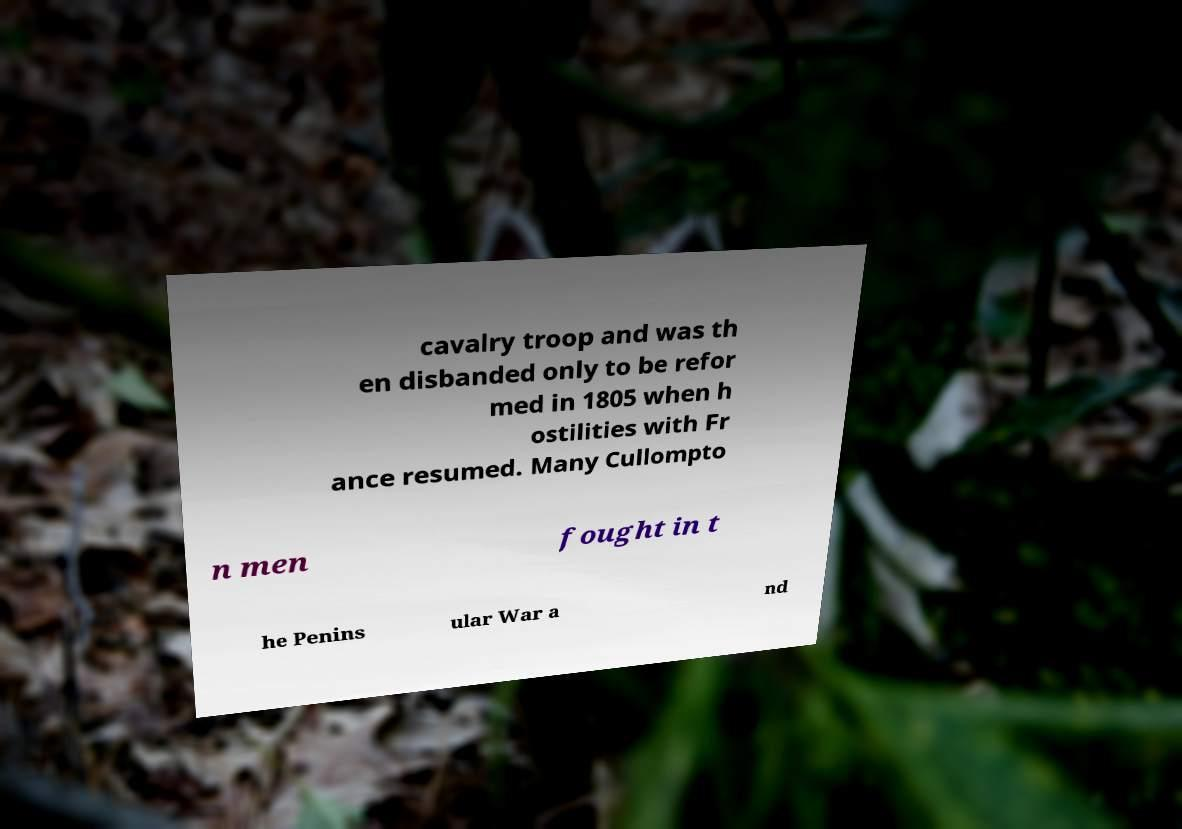I need the written content from this picture converted into text. Can you do that? cavalry troop and was th en disbanded only to be refor med in 1805 when h ostilities with Fr ance resumed. Many Cullompto n men fought in t he Penins ular War a nd 